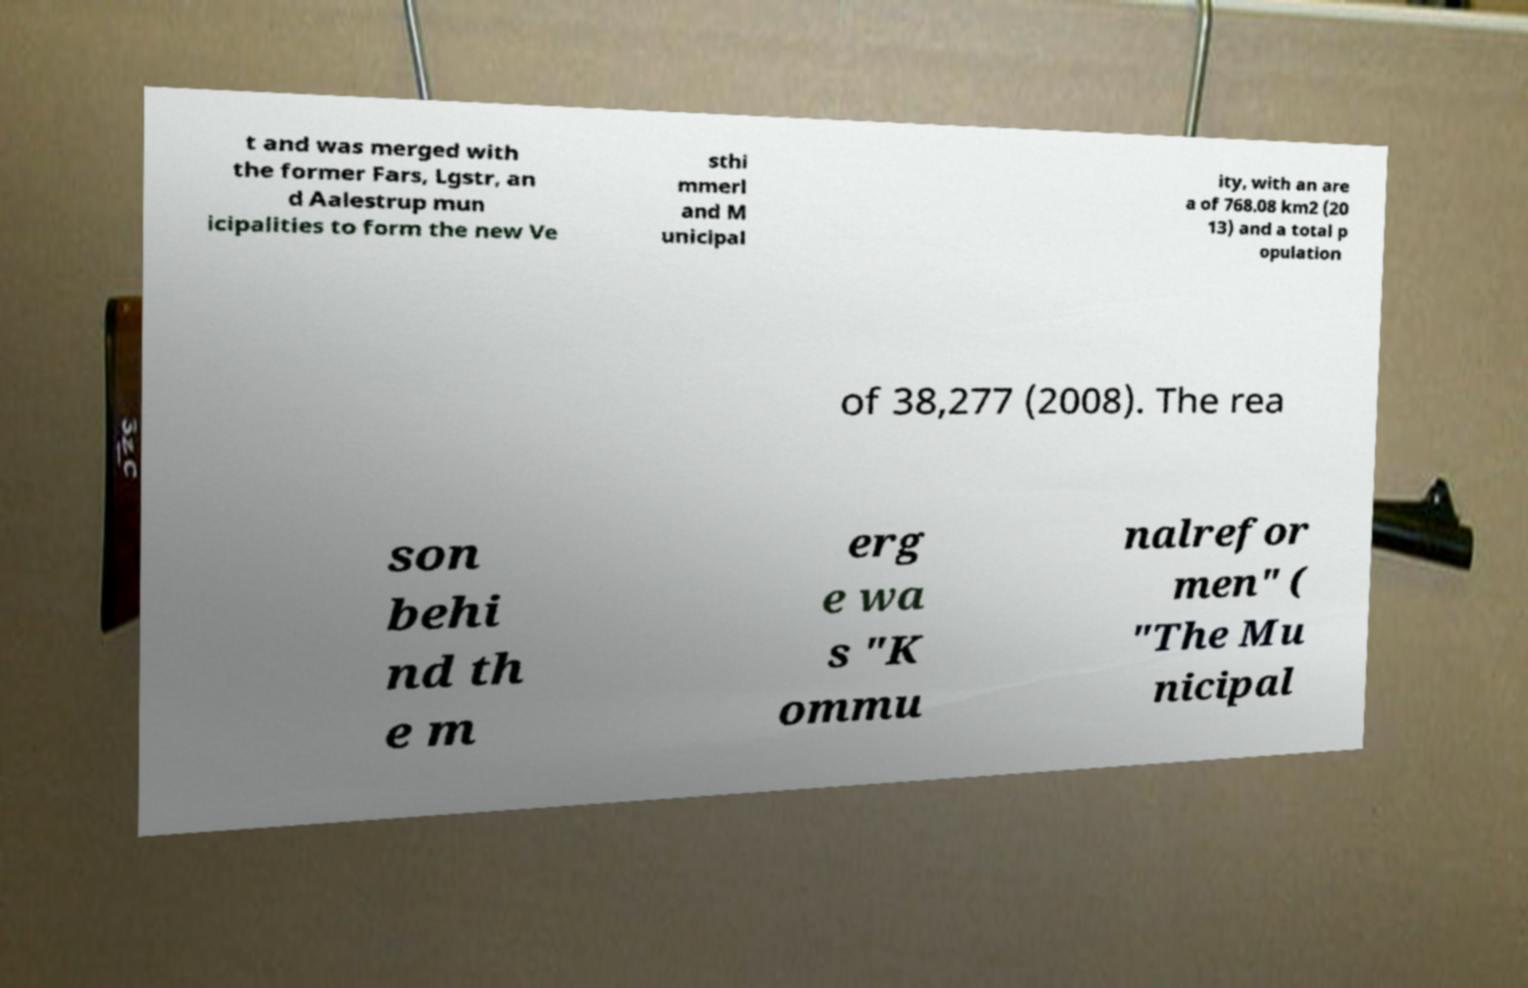Please read and relay the text visible in this image. What does it say? t and was merged with the former Fars, Lgstr, an d Aalestrup mun icipalities to form the new Ve sthi mmerl and M unicipal ity, with an are a of 768.08 km2 (20 13) and a total p opulation of 38,277 (2008). The rea son behi nd th e m erg e wa s "K ommu nalrefor men" ( "The Mu nicipal 